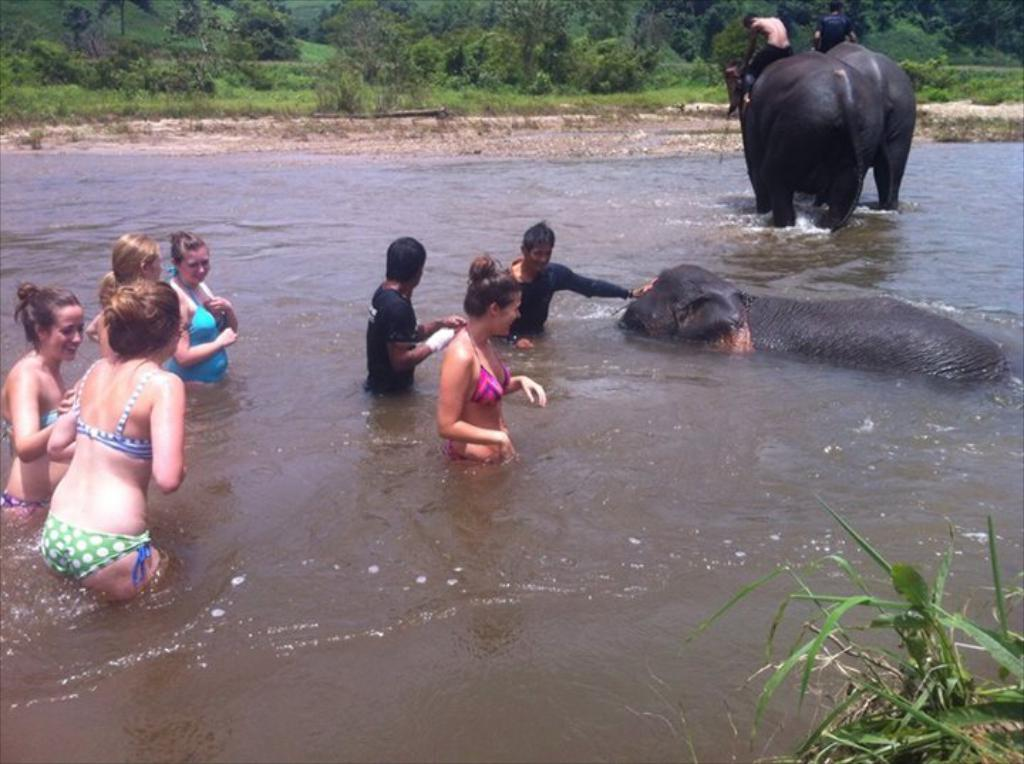What is happening in the foreground of the image? There is a group of people in the water, and there are three elephants in the foreground of the image. What can be seen in the background of the image? There are trees and mountains in the background of the image. What might be the location of the image? The image may have been taken near a lake, given the presence of water and the surrounding landscape. How far away is the airplane from the group of people in the image? There is no airplane present in the image, so it is not possible to determine the distance between an airplane and the group of people. 